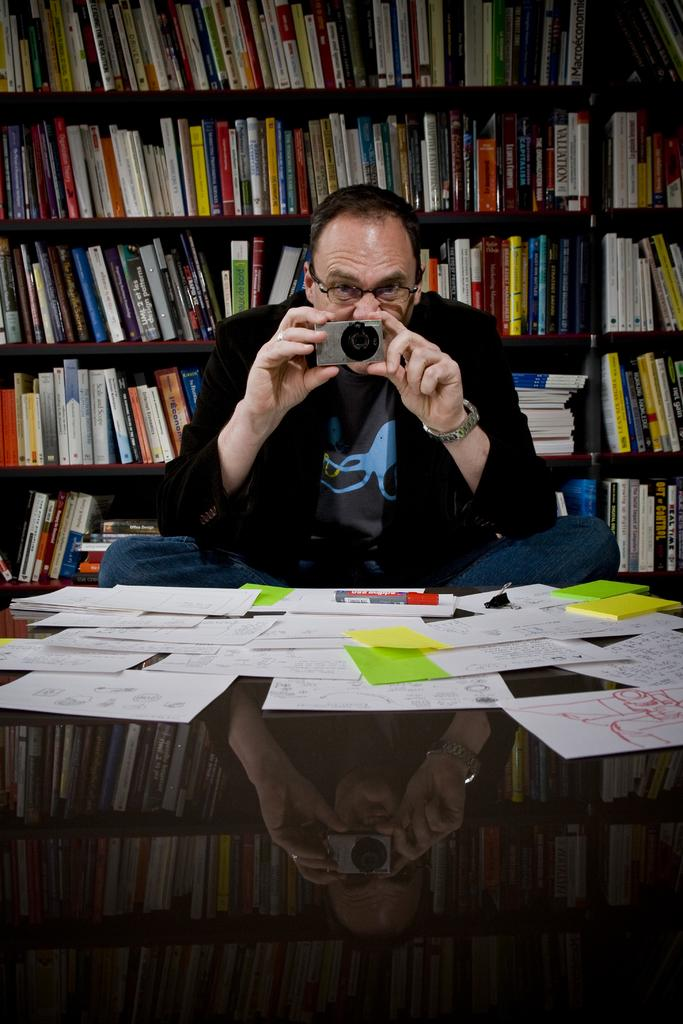What objects are on the table in the image? There are papers, a marker, and a binder clip on the table. What is the man in the image doing? The man is sitting and holding a camera. What can be seen in the background of the image? There are books in the background, and they are in racks. What type of fog can be seen in the image? There is no fog present in the image. What kind of garden is visible in the background of the image? There is no garden visible in the image; it features a man sitting at a table with papers, a marker, and a binder clip, and books in racks in the background. 